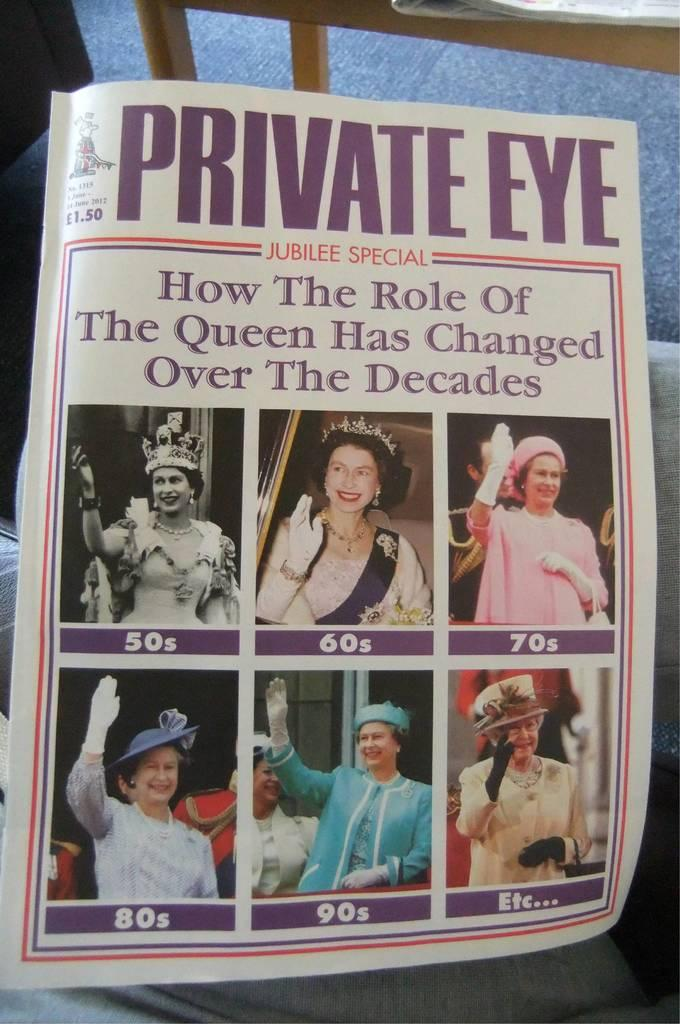What is the main object in the image? There is a book in the image. What type of content does the book contain? The book contains text and images of women. What is the location of the book in the image? The book is on a table in the image. What other object is on the table? A paper is placed on the table. How many planes are flying over the book in the image? There are no planes visible in the image. Can you describe the kick of the top in the image? There is no top or kick present in the image. 